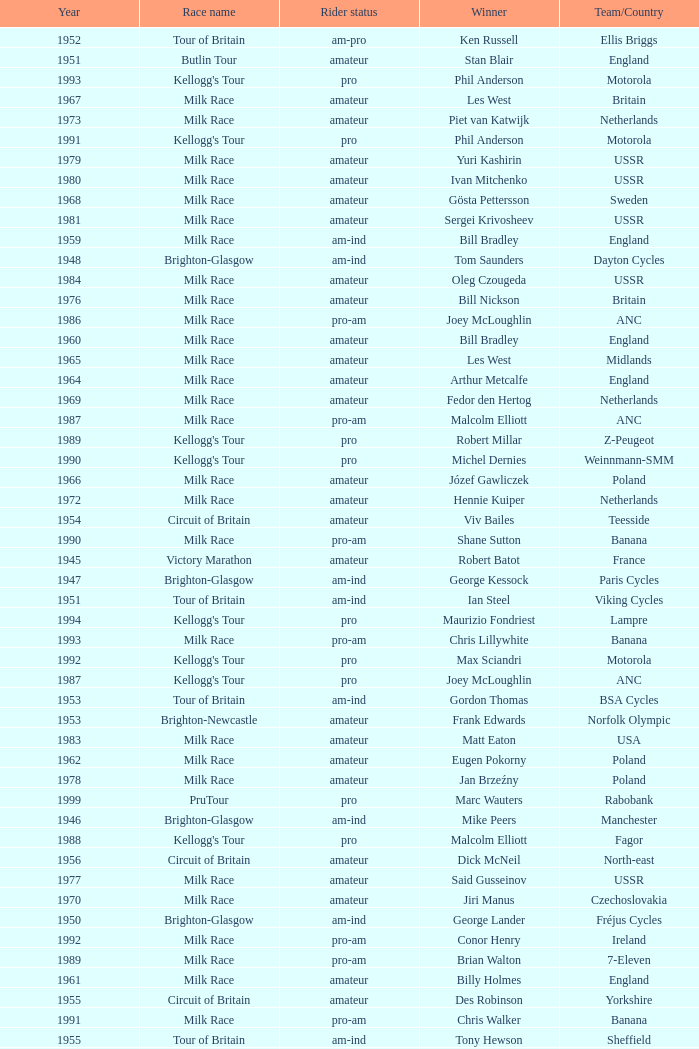What is the rider status for the 1971 netherlands team? Amateur. 